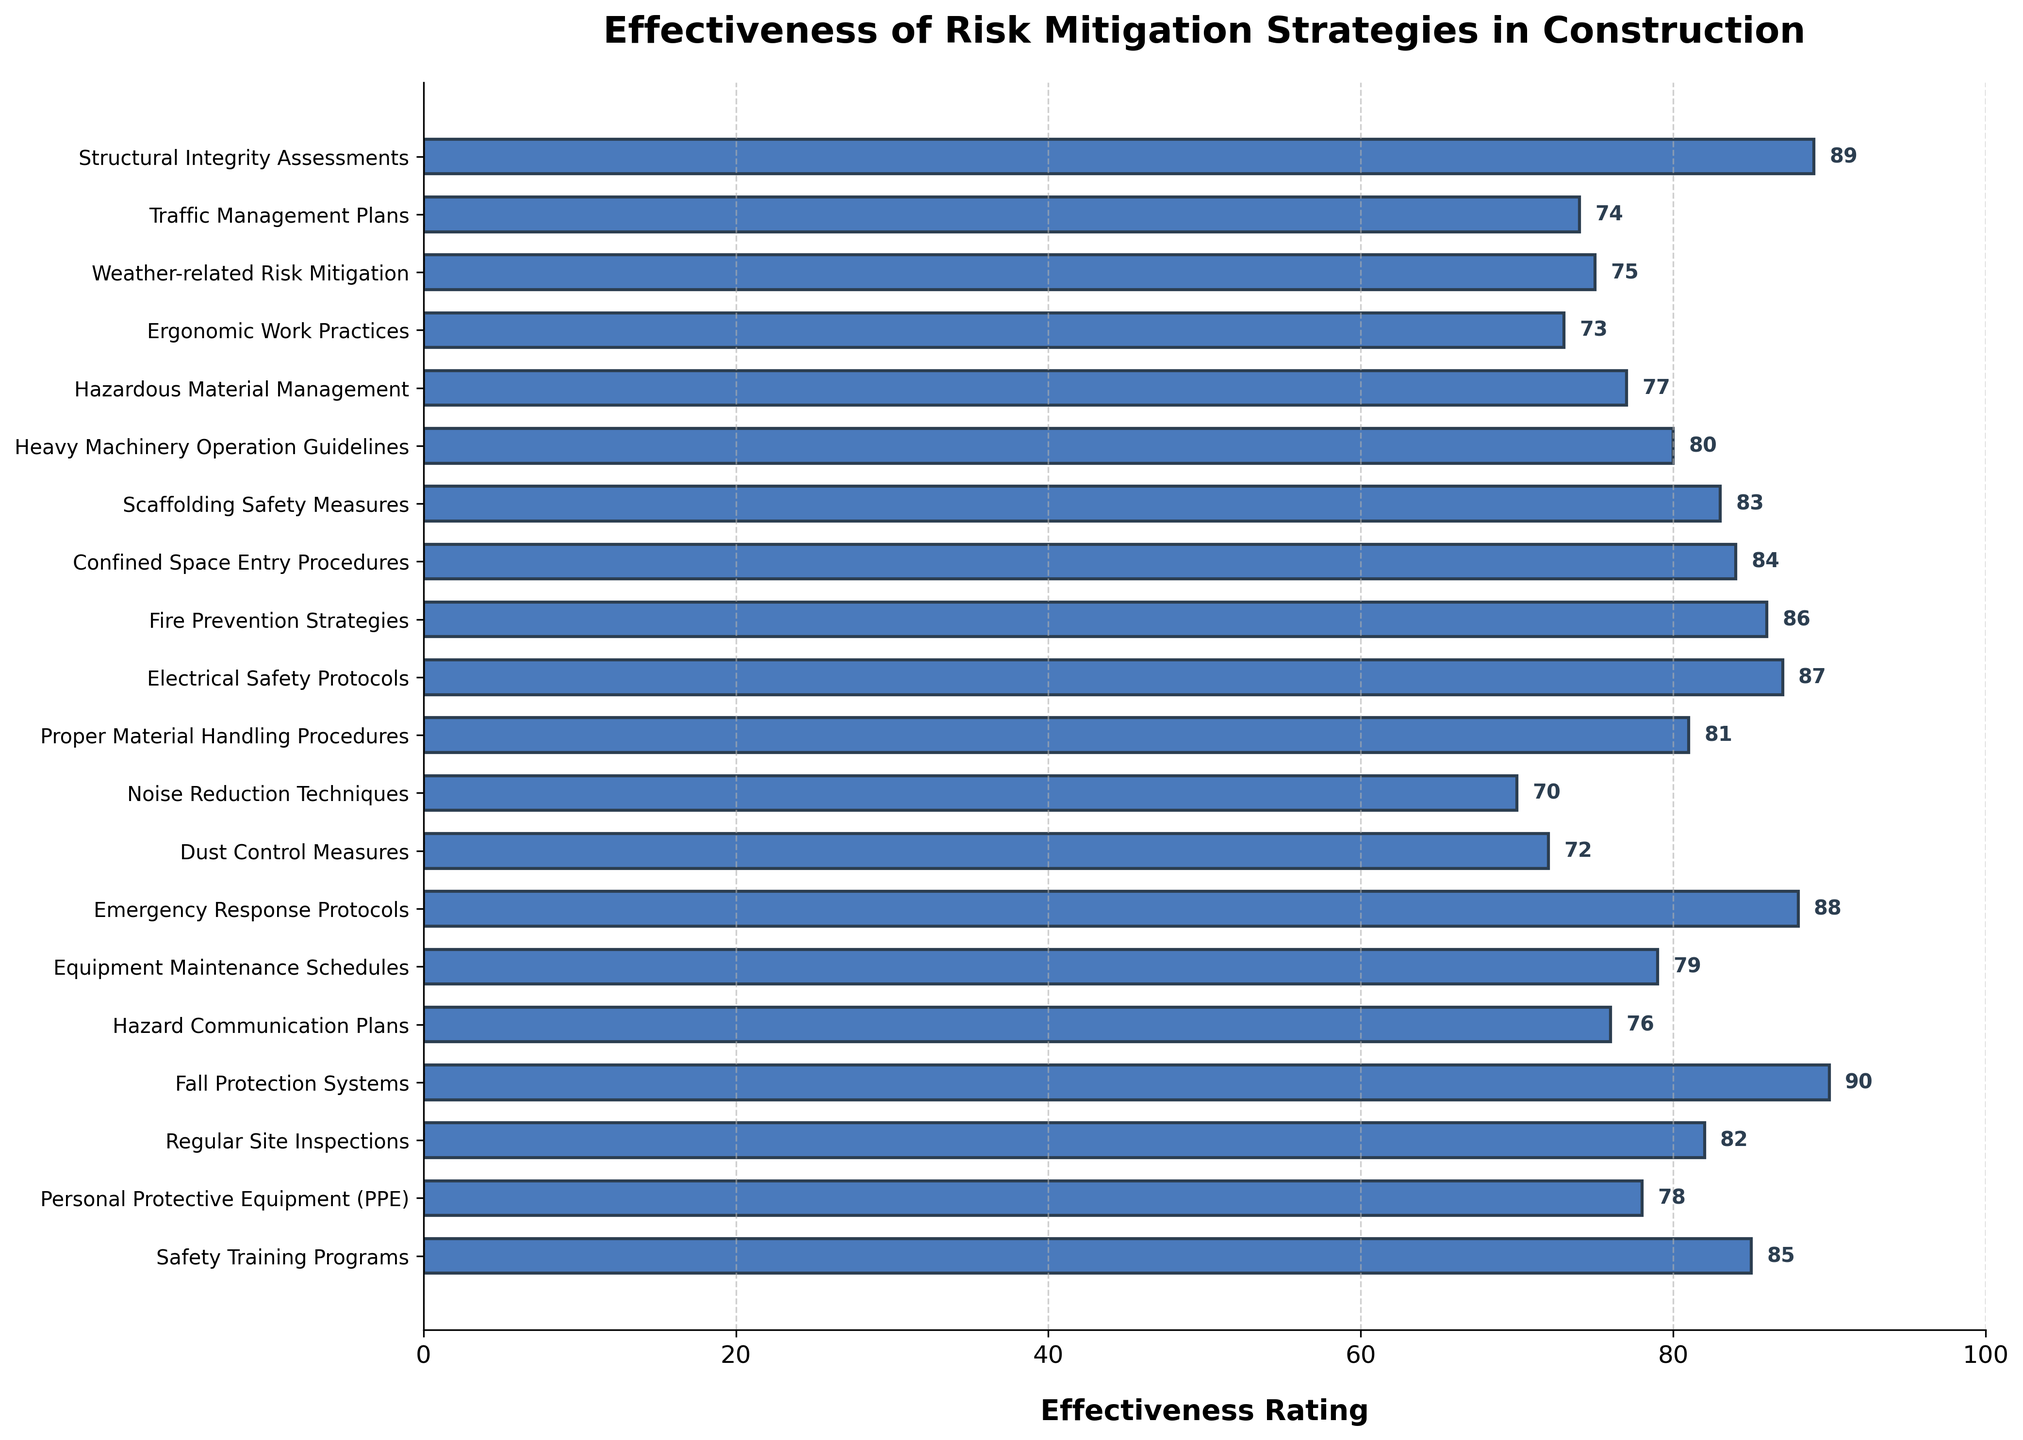What is the highest effectiveness rating among the risk mitigation strategies? Look at the bar chart and identify the bar with the longest length. The strategy associated with this bar represents the highest effectiveness rating, which is 90 for Fall Protection Systems.
Answer: 90 Which strategy has the lowest effectiveness rating in the chart? Scan the bar chart to find the shortest bar. The shortest bar corresponds to Noise Reduction Techniques with a rating of 70.
Answer: 70 How many risk mitigation strategies have an effectiveness rating of 85 or higher? Count the bars that have lengths indicative of ratings of 85 or above. They are Fall Protection Systems (90), Structural Integrity Assessments (89), Emergency Response Protocols (88), Electrical Safety Protocols (87), Fire Prevention Strategies (86), Safety Training Programs (85). There are 6 bars in total.
Answer: 6 Which two strategies have the closest effectiveness ratings and what are those ratings? Identify pairs of bars with the smallest differences in length. Equipment Maintenance Schedules (79) and Personal Protective Equipment (78) have the closest ratings.
Answer: Equipment Maintenance Schedules (79) and Personal Protective Equipment (78) What is the average effectiveness rating for all risk mitigation strategies? Sum up all the effectiveness ratings and divide by the number of strategies. (85 + 78 + 82 + 90 + 76 + 79 + 88 + 72 + 70 + 81 + 87 + 86 + 84 + 83 + 80 + 77 + 73 + 75 + 74 + 89) / 20 = 82
Answer: 82 Which risk mitigation strategy is rated higher, Safety Training Programs or Hazard Communication Plans? By how much? Compare the lengths of the bars for Safety Training Programs and Hazard Communication Plans. Safety Training Programs have an effectiveness rating of 85, and Hazard Communication Plans have an effectiveness rating of 76. The difference is 85 - 76 = 9.
Answer: Safety Training Programs by 9 